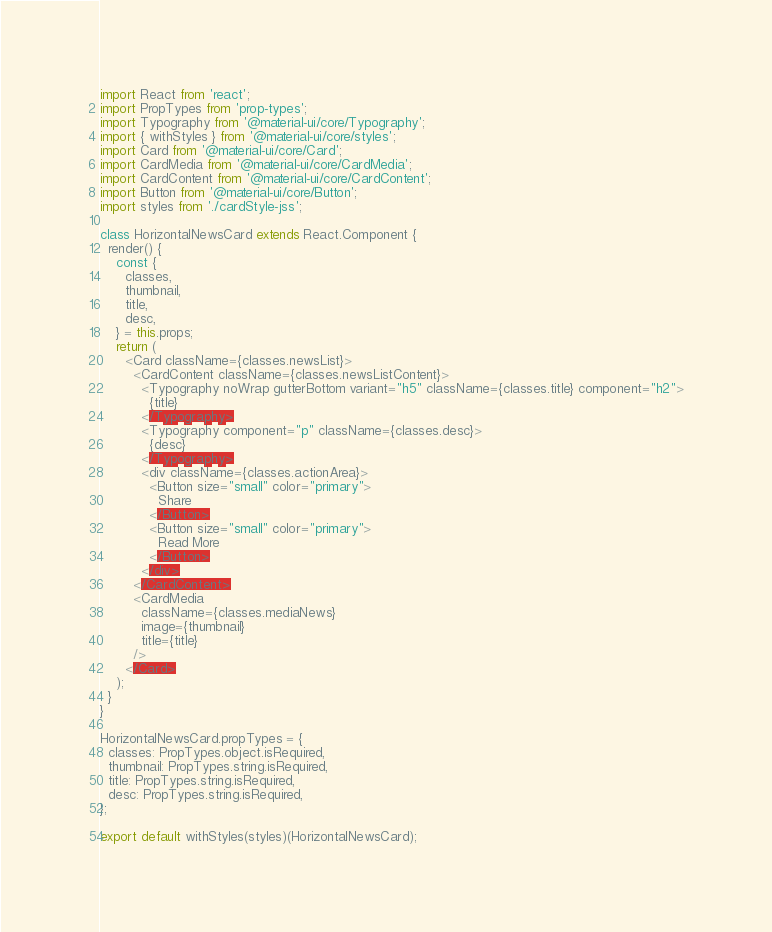Convert code to text. <code><loc_0><loc_0><loc_500><loc_500><_JavaScript_>import React from 'react';
import PropTypes from 'prop-types';
import Typography from '@material-ui/core/Typography';
import { withStyles } from '@material-ui/core/styles';
import Card from '@material-ui/core/Card';
import CardMedia from '@material-ui/core/CardMedia';
import CardContent from '@material-ui/core/CardContent';
import Button from '@material-ui/core/Button';
import styles from './cardStyle-jss';

class HorizontalNewsCard extends React.Component {
  render() {
    const {
      classes,
      thumbnail,
      title,
      desc,
    } = this.props;
    return (
      <Card className={classes.newsList}>
        <CardContent className={classes.newsListContent}>
          <Typography noWrap gutterBottom variant="h5" className={classes.title} component="h2">
            {title}
          </Typography>
          <Typography component="p" className={classes.desc}>
            {desc}
          </Typography>
          <div className={classes.actionArea}>
            <Button size="small" color="primary">
              Share
            </Button>
            <Button size="small" color="primary">
              Read More
            </Button>
          </div>
        </CardContent>
        <CardMedia
          className={classes.mediaNews}
          image={thumbnail}
          title={title}
        />
      </Card>
    );
  }
}

HorizontalNewsCard.propTypes = {
  classes: PropTypes.object.isRequired,
  thumbnail: PropTypes.string.isRequired,
  title: PropTypes.string.isRequired,
  desc: PropTypes.string.isRequired,
};

export default withStyles(styles)(HorizontalNewsCard);
</code> 